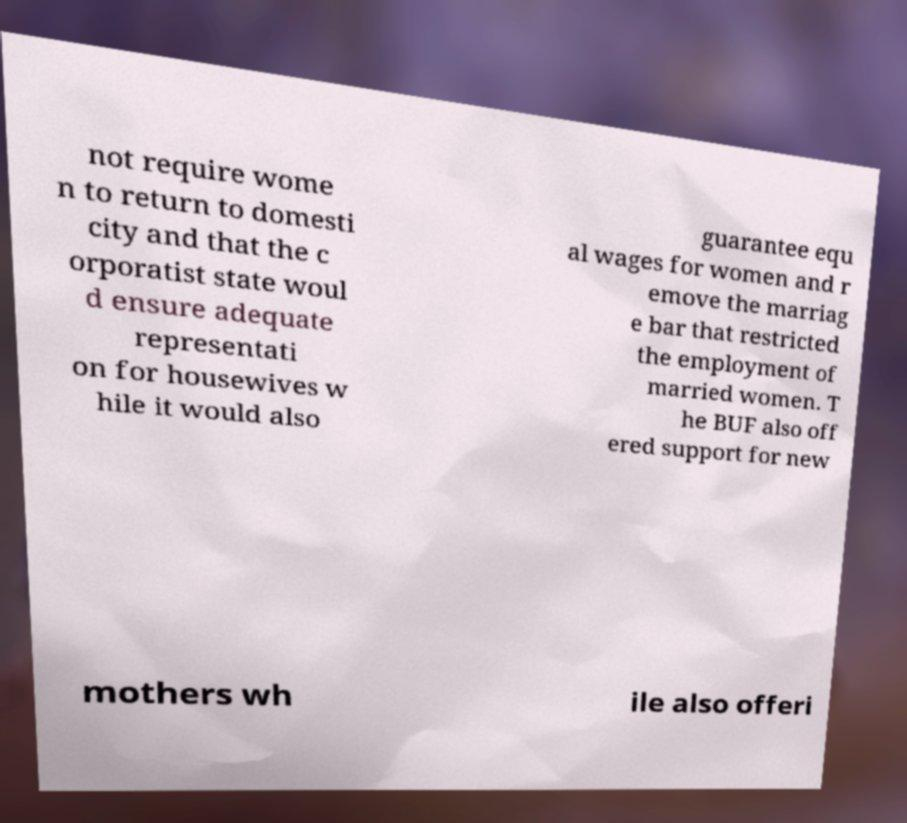Could you assist in decoding the text presented in this image and type it out clearly? not require wome n to return to domesti city and that the c orporatist state woul d ensure adequate representati on for housewives w hile it would also guarantee equ al wages for women and r emove the marriag e bar that restricted the employment of married women. T he BUF also off ered support for new mothers wh ile also offeri 